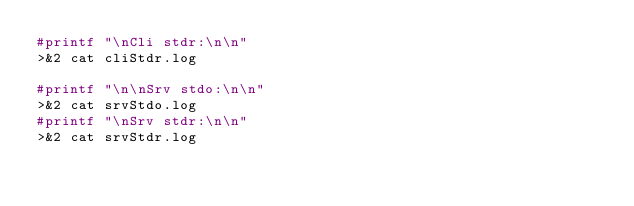<code> <loc_0><loc_0><loc_500><loc_500><_Bash_>#printf "\nCli stdr:\n\n"
>&2 cat cliStdr.log

#printf "\n\nSrv stdo:\n\n"
>&2 cat srvStdo.log
#printf "\nSrv stdr:\n\n"
>&2 cat srvStdr.log
</code> 